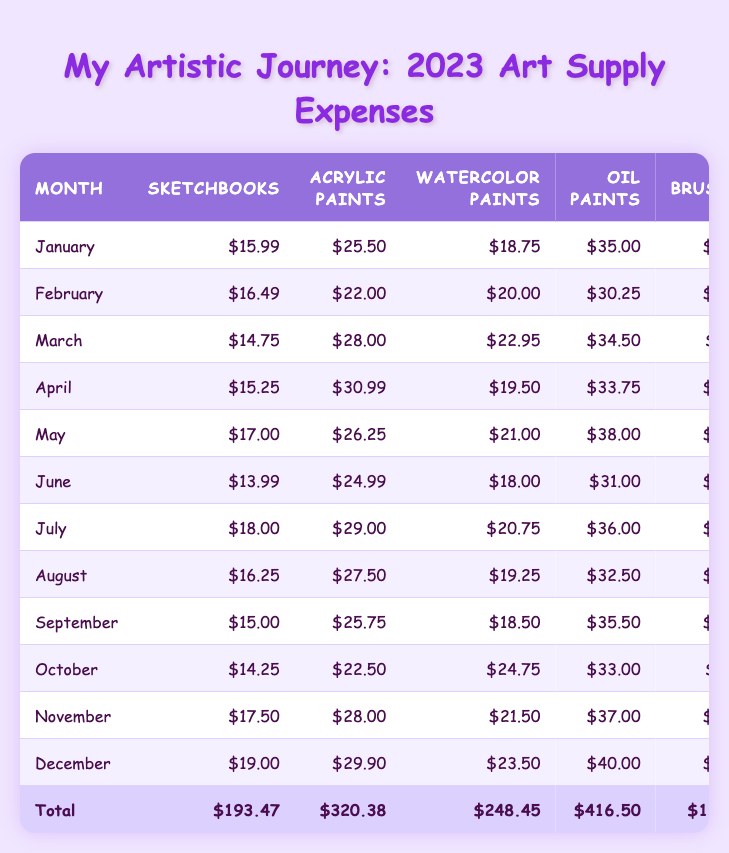What was the total expenditure on oil paints for the entire year? By summing the monthly expenditures listed for oil paints: $35.00 + $30.25 + $34.50 + $33.75 + $38.00 + $31.00 + $36.00 + $32.50 + $35.50 + $33.00 + $37.00 + $40.00 = $416.50.
Answer: $416.50 Which month had the highest expenditure on sketchbooks? By comparing the values for sketchbooks across all months, the highest value is $19.00 in December.
Answer: December What is the average spending on markers over the year? Summing the spending on markers: $10.99 + $9.00 + $11.49 + $8.75 + $10.00 + $9.99 + $8.50 + $7.75 + $9.49 + $10.25 + $9.25 + $12.50 = $117.96; then, dividing by 12 (the number of months), gives $117.96 / 12 = $9.83.
Answer: $9.83 Did the spending on acrylic paints exceed $300 in any month? Looking at the individual month's values for acrylic paints, the maximum is $30.99 (April), which does not exceed $300 in any month since all monthly values are far less.
Answer: No What was the month with the highest total expenditure? Comparing total expenditures (last column), December has the highest total at $194.90 while the other months are lower.
Answer: December How much more was spent on watercolors in March than in June? The expenditure on watercolors in March is $22.95 and in June is $18.00. Therefore, $22.95 - $18.00 = $4.95 more was spent in March than in June.
Answer: $4.95 What percentage of the total art supply expenditure was spent on pastels throughout the year? The total spending on pastels is $76.25; the overall total spending is $2021.45. Thus, (76.25 / 2021.45) * 100 = 3.77%.
Answer: 3.77% Which type of supply had the lowest total expenditure? By summing the expenditures for each type (last row values), pastels at $149.75 are lower compared to other supplies.
Answer: Pastels In which month did spending on brushes peak, and what was the amount? The brush expenditure values show that July records the highest at $13.80, compared to other months being lower.
Answer: July, $13.80 How much did you spend on art supplies in July compared to January? Total expenditures for July are $178.30 and for January are $165.23. The difference is $178.30 - $165.23 = $13.07 more in July.
Answer: $13.07 more 